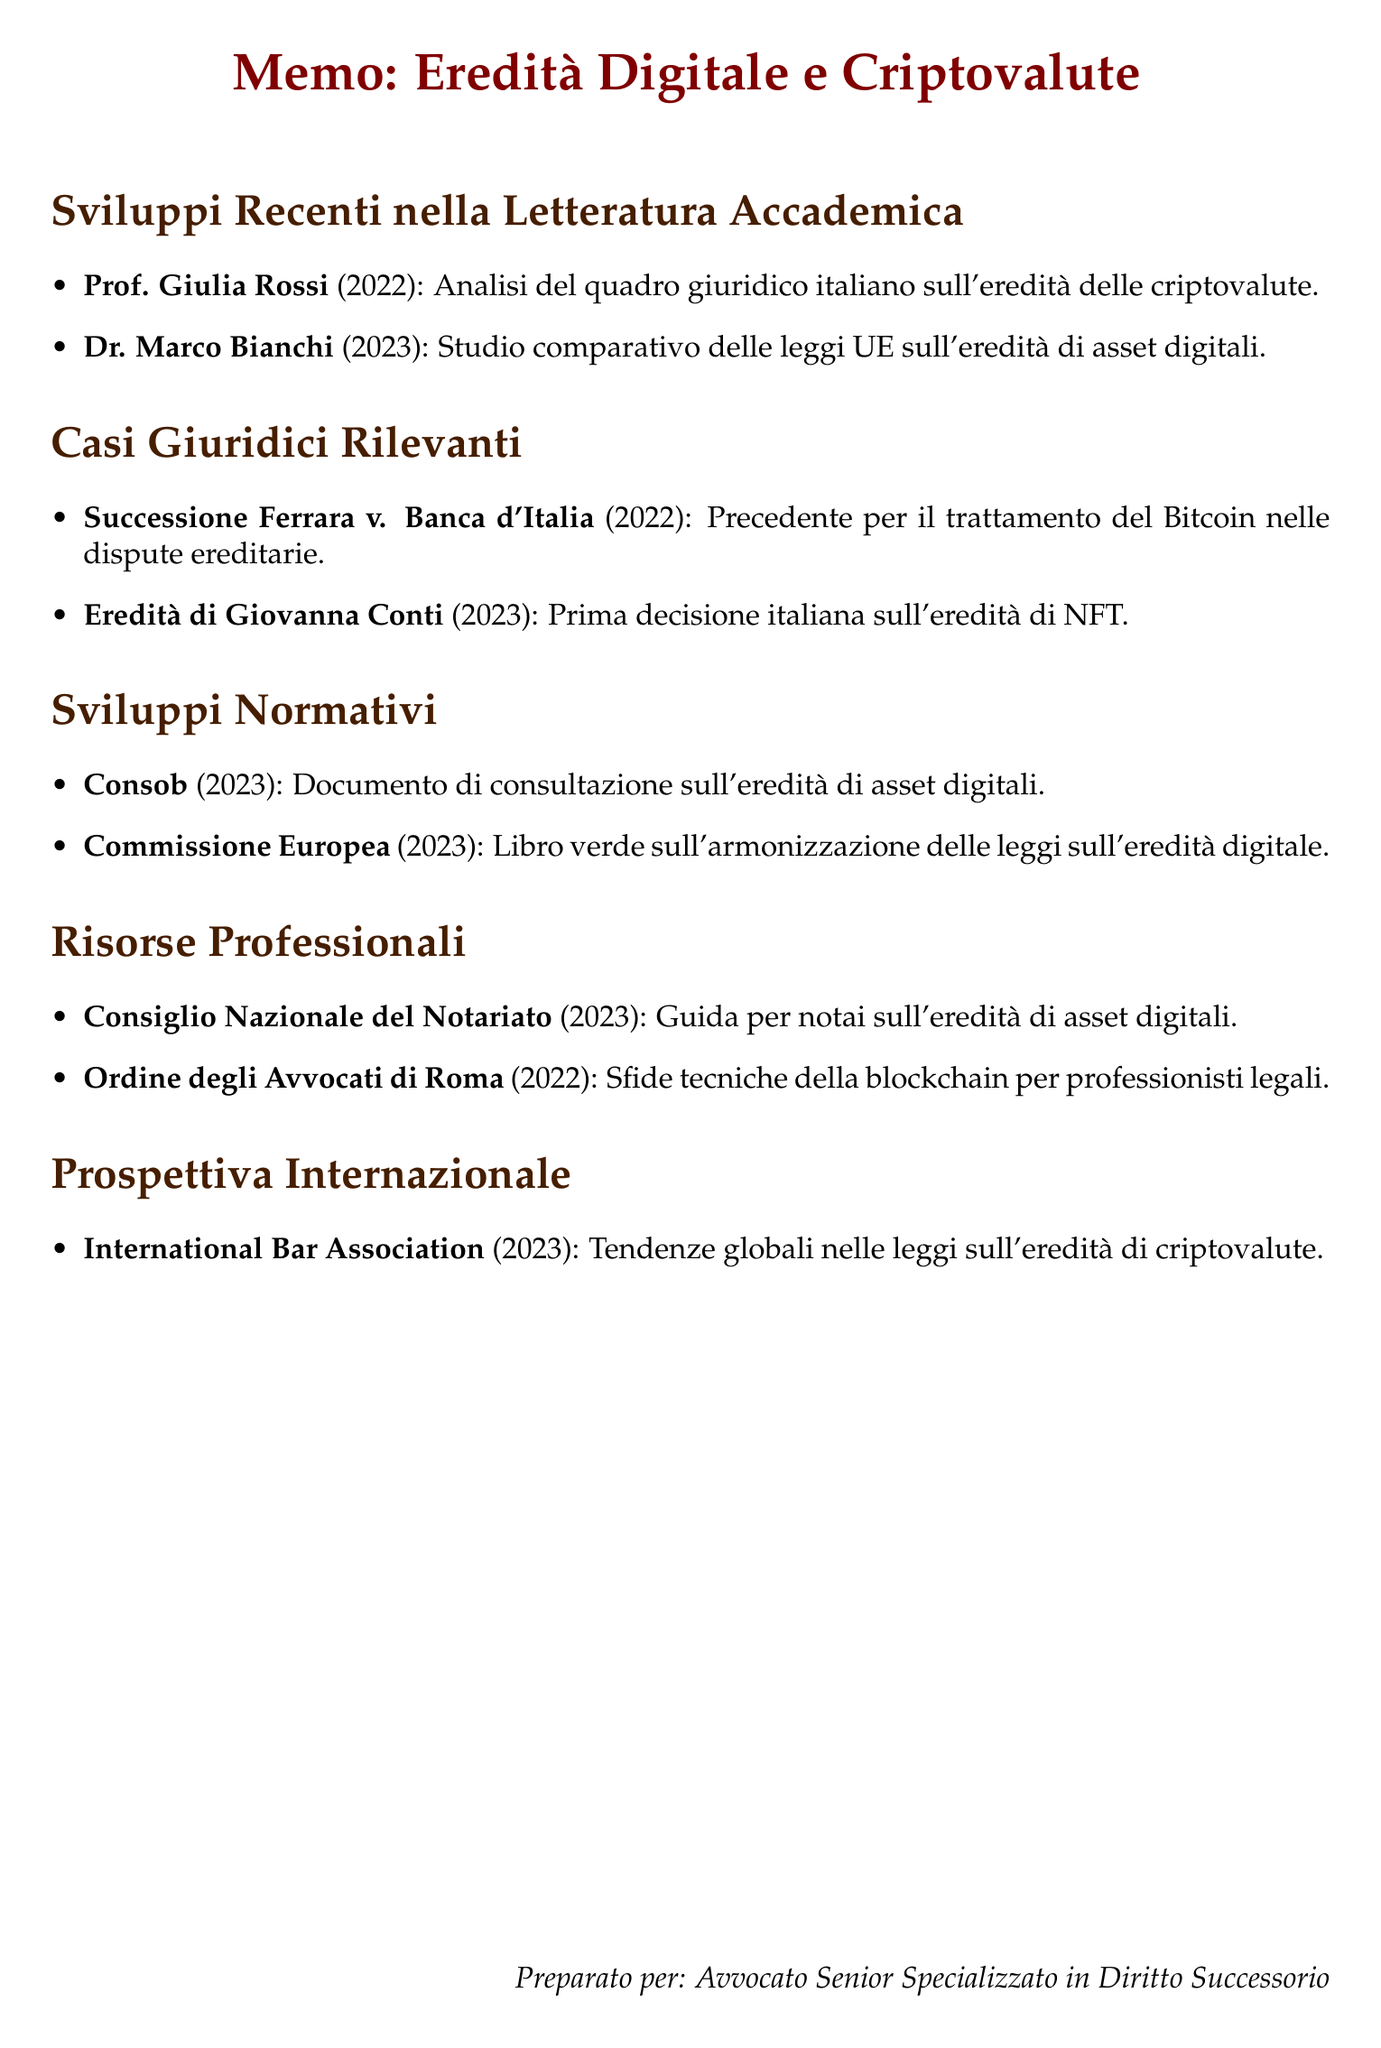What is the title of Prof. Giulia Rossi's paper? The title is found in the section on recent academic papers, presenting her analysis of cryptocurrency inheritance.
Answer: The Digital Afterlife: Inheritance of Cryptocurrency Assets in the Italian Legal Framework What year was the "Successione Ferrara v. Banca d'Italia" case decided? The year of the case is indicated in the section on relevant legal cases, detailing significant inheritance disputes.
Answer: 2022 What is the main focus of Dr. Marco Bianchi's research? The research focuses on digital asset inheritance laws within the context of EU member states, as noted in the academic literature section.
Answer: Overview of digital asset inheritance laws across EU member states Which regulatory body proposed guidelines regarding digital assets? The regulatory body is mentioned in the section on regulatory developments, which discusses guidelines for financial institutions.
Answer: Consob What significant decision was made in the "Estate of Giovanna Conti" case? The significance is outlined in the legal cases section, marking a first in Italian legal decisions regarding a specific type of digital asset.
Answer: First Italian court decision addressing inheritance of non-fungible tokens (NFTs) What does the 2023 European Commission Green Paper propose? The proposal is detailed in the regulatory developments section of the memo, focusing on the harmonization of laws across the EU.
Answer: Proposal for EU-wide standards on digital asset inheritance What resource was published by the Consiglio Nazionale del Notariato? The resource is noted in the professional resources section, focusing on practical guidance for notaries regarding digital assets.
Answer: Digital Asset Inheritance: A Guide for Italian Notaries Which international organization provided insights on trends in cryptocurrency inheritance laws? The organization is mentioned in the international perspective section, comparing different jurisdictions' approaches to digital asset regulation.
Answer: International Bar Association 